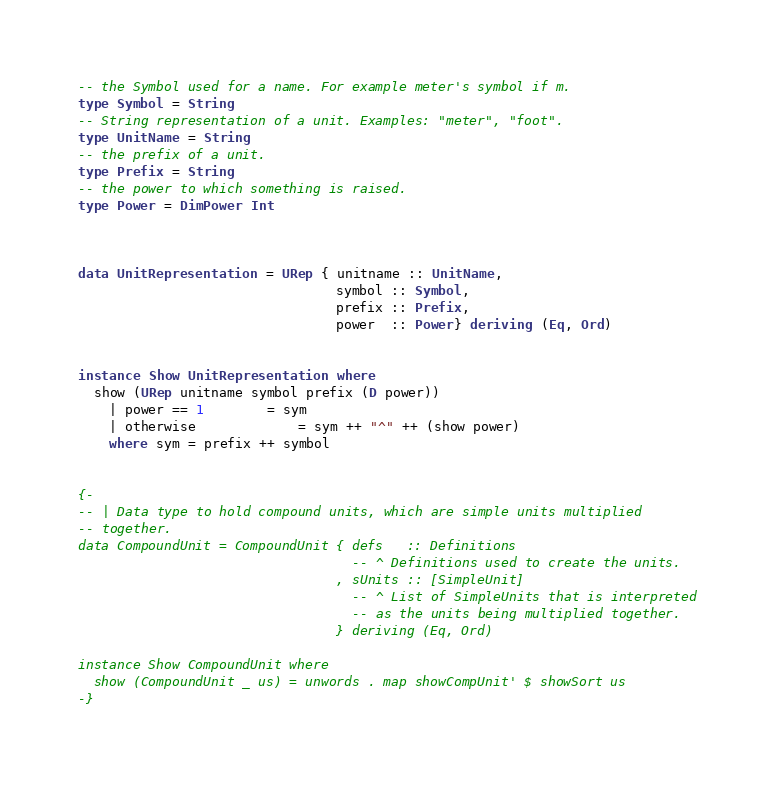Convert code to text. <code><loc_0><loc_0><loc_500><loc_500><_Haskell_>
-- the Symbol used for a name. For example meter's symbol if m.
type Symbol = String
-- String representation of a unit. Examples: "meter", "foot".
type UnitName = String
-- the prefix of a unit.
type Prefix = String
-- the power to which something is raised.
type Power = DimPower Int



data UnitRepresentation = URep { unitname :: UnitName, 
                                 symbol :: Symbol, 
                                 prefix :: Prefix, 
                                 power  :: Power} deriving (Eq, Ord)


instance Show UnitRepresentation where
  show (URep unitname symbol prefix (D power))
    | power == 1        = sym
    | otherwise             = sym ++ "^" ++ (show power)
    where sym = prefix ++ symbol


{-
-- | Data type to hold compound units, which are simple units multiplied
-- together.
data CompoundUnit = CompoundUnit { defs   :: Definitions
                                   -- ^ Definitions used to create the units.
                                 , sUnits :: [SimpleUnit]
                                   -- ^ List of SimpleUnits that is interpreted
                                   -- as the units being multiplied together.
                                 } deriving (Eq, Ord)

instance Show CompoundUnit where
  show (CompoundUnit _ us) = unwords . map showCompUnit' $ showSort us
-}</code> 